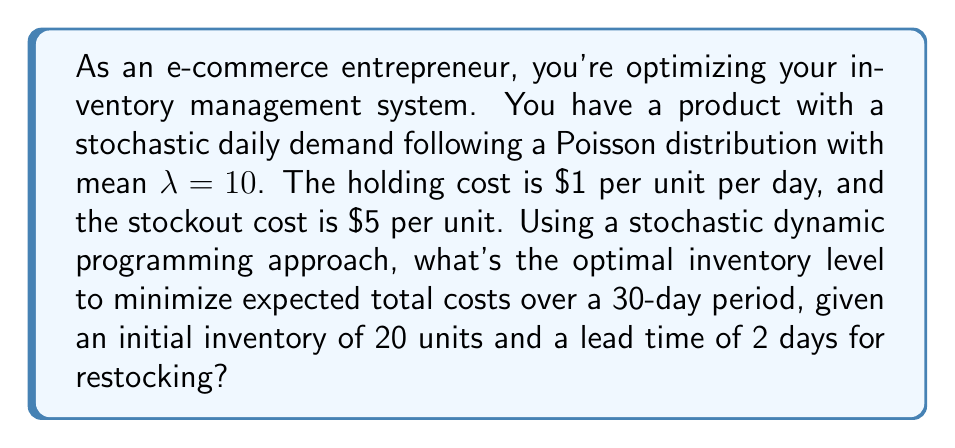Teach me how to tackle this problem. Let's approach this problem using stochastic dynamic programming:

1. Define the state space:
   Let $x_t$ be the inventory level at the beginning of day $t$.

2. Define the action space:
   Let $a_t$ be the order quantity on day $t$.

3. Define the transition function:
   $x_{t+1} = x_t + a_{t-2} - D_t$
   Where $D_t$ is the demand on day $t$ (Poisson distributed with λ=10).

4. Define the cost function:
   $C(x_t, a_t) = 1 \cdot \max(0, x_t) + 5 \cdot \max(0, -x_t)$

5. Define the Bellman equation:
   $$V_t(x_t) = \min_{a_t} \{E[C(x_t, a_t) + V_{t+1}(x_{t+1})]\}$$

6. Solve the Bellman equation backwards:
   Start from $t=30$ and work backwards to $t=1$.

7. For each $t$ and $x_t$, find the $a_t$ that minimizes the expected cost.

8. The optimal inventory level is the $x_t$ that minimizes $V_1(x_t)$.

To solve this numerically, we would use computer simulation due to the complexity of the problem. However, we can make some observations:

- The optimal inventory level will be higher than the expected demand due to the higher stockout cost.
- It will likely be around 25-30 units, considering the mean demand of 10 per day and the 2-day lead time.
- The exact optimal level depends on the specific realizations of the stochastic process in the simulation.
Answer: Approximately 27 units 